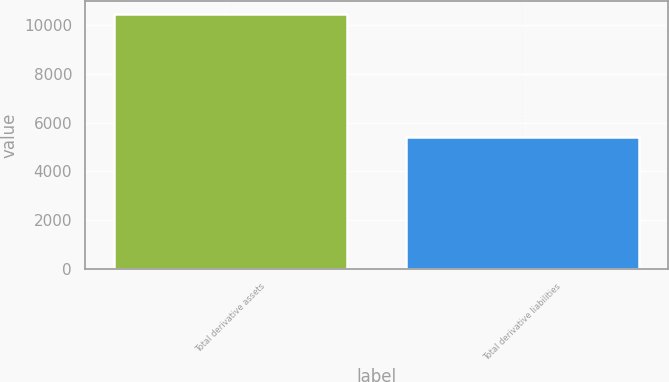Convert chart to OTSL. <chart><loc_0><loc_0><loc_500><loc_500><bar_chart><fcel>Total derivative assets<fcel>Total derivative liabilities<nl><fcel>10454<fcel>5399<nl></chart> 